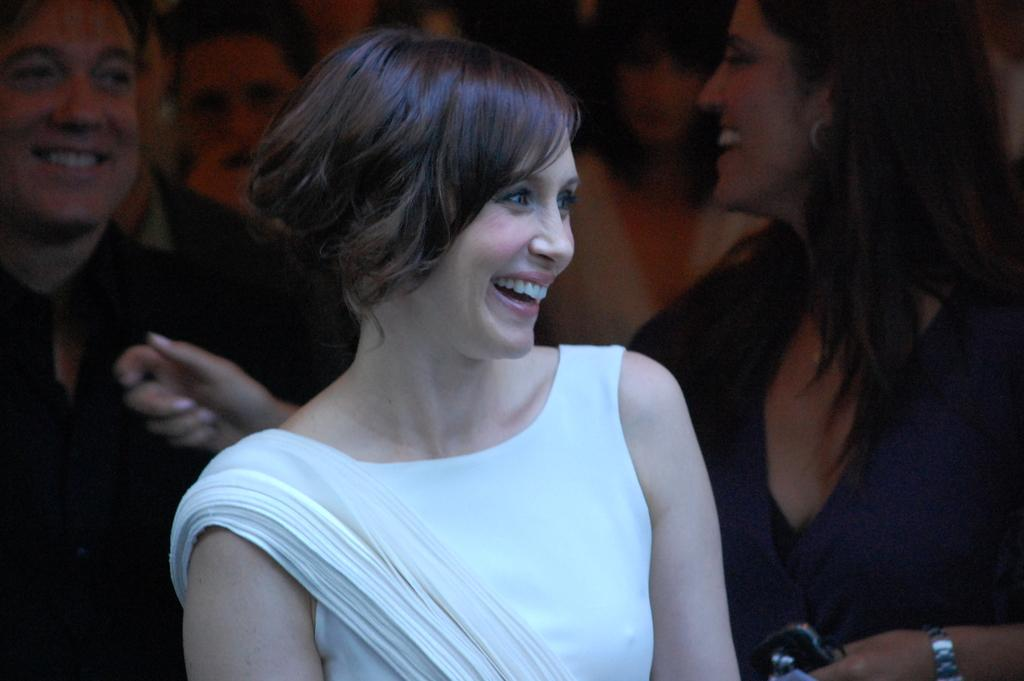Who is the main subject in the foreground of the image? There is a lady in the foreground of the image. What is the lady wearing? The lady is wearing a white dress. What expression does the lady have? The lady is smiling. What can be observed about the people in the background of the image? There are many people in the background of the image, and they are all smiling. What type of shirt is the bee wearing in the image? There is no bee present in the image, and therefore no shirt to describe. 